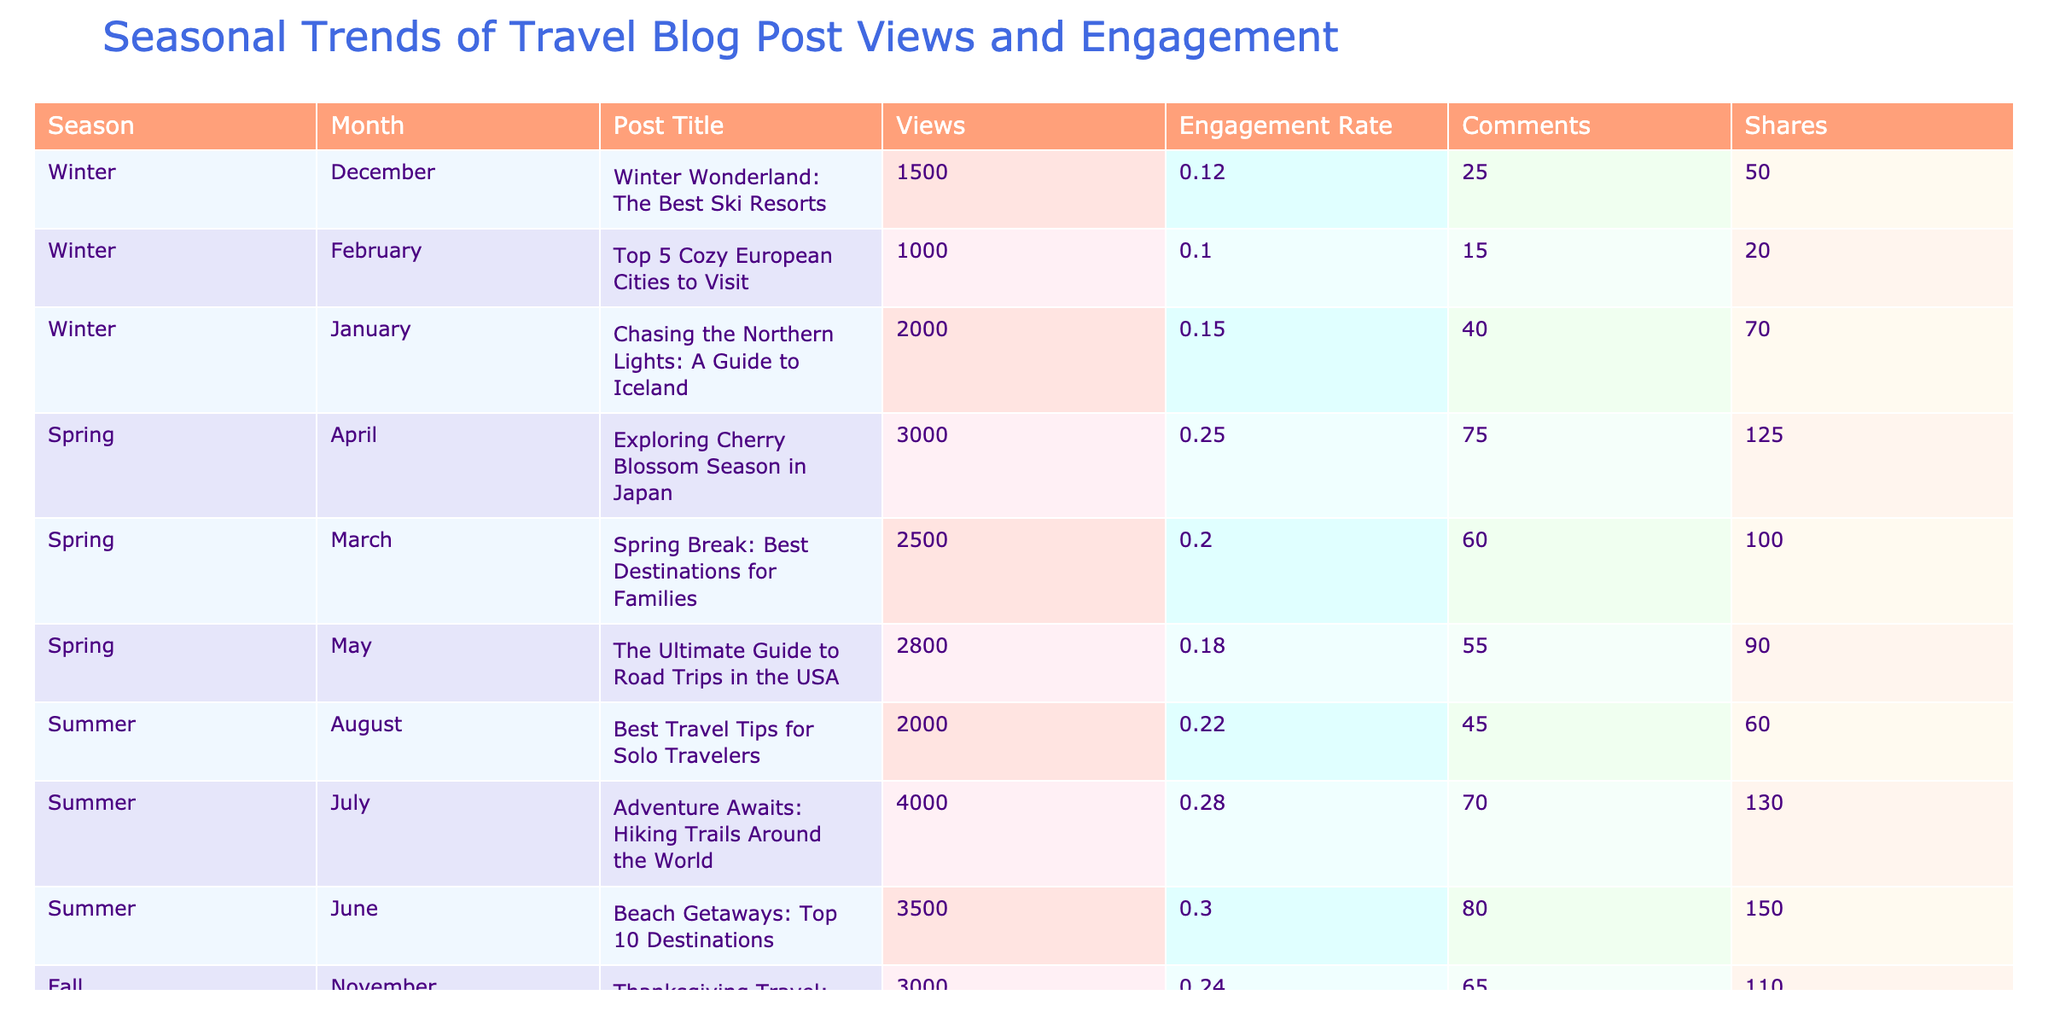What is the post with the highest views? By examining the "Views" column, the post titled "Adventure Awaits: Hiking Trails Around the World" has the highest views listed at 4000.
Answer: 4000 Which season has the highest average engagement rate? First, I will calculate the average engagement rate for each season: Winter (0.12 + 0.15 + 0.10)/3 = 0.123, Spring (0.20 + 0.25 + 0.18)/3 = 0.213, Summer (0.30 + 0.28 + 0.22)/3 = 0.267, Fall (0.15 + 0.19 + 0.24)/3 = 0.193. The highest average is for Summer at 0.267.
Answer: Summer How many total shares did posts receive in Fall? I will sum the "Shares" column for Fall: October (80) + September (30) + November (110) = 220.
Answer: 220 Is there a post titled "Exploring Cherry Blossom Season in Japan"? I can check the "Post Title" column for this specific title. The title appears in the table, confirming its existence.
Answer: Yes What is the difference in views between the highest and lowest performing post in Spring? The highest views in Spring is "Exploring Cherry Blossom Season in Japan" at 3000, and the lowest is "Spring Break: Best Destinations for Families" at 2500. The difference is 3000 - 2500 = 500.
Answer: 500 Which post had the most comments and how many did it receive? I look at the "Comments" column. The post "Exploring Cherry Blossom Season in Japan" received the most comments, totaling 75.
Answer: 75 What is the total number of views for winter posts? I will sum the "Views" for all winter posts: December (1500) + January (2000) + February (1000) = 4500.
Answer: 4500 Does the post "Thanksgiving Travel: Best Places to Eat" have more shares than comments? For the post "Thanksgiving Travel: Best Places to Eat", it has 110 shares and 65 comments. Since 110 is greater than 65, the statement is true.
Answer: Yes What is the season with the lowest total views? To find this, I need to sum views for each season: Winter (1500 + 2000 + 1000 = 4500), Spring (2500 + 3000 + 2800 = 8300), Summer (3500 + 4000 + 2000 = 9500), and Fall (1800 + 2200 + 3000 = 7000). The lowest total views is Winter with 4500.
Answer: Winter How many total views did summer posts receive compared to spring posts? Summer totals: June (3500) + July (4000) + August (2000) = 9500, and Spring totals: March (2500) + April (3000) + May (2800) = 8300. Summer has 9500 which is greater than Spring's 8300 by 1200.
Answer: 1200 more views in Summer 